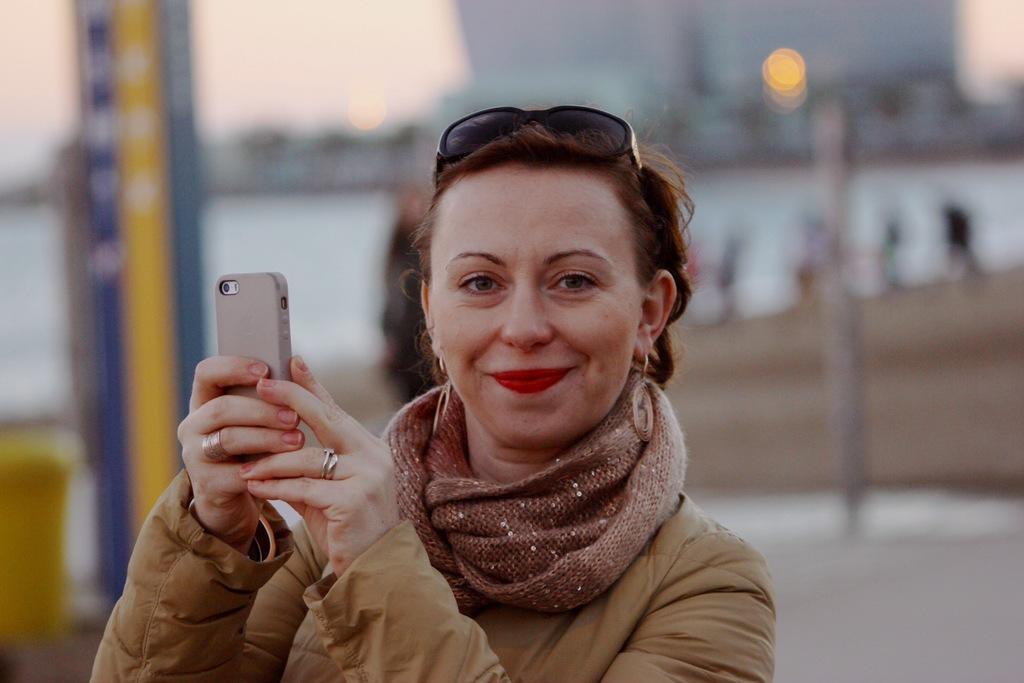Can you describe this image briefly? In this image we can see a woman holding a mobile and she is smiling. She has a glasses on her head. The background is blurry. 